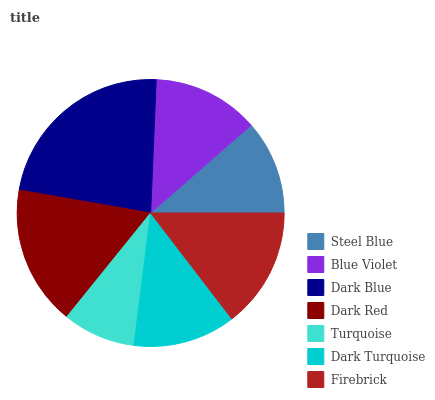Is Turquoise the minimum?
Answer yes or no. Yes. Is Dark Blue the maximum?
Answer yes or no. Yes. Is Blue Violet the minimum?
Answer yes or no. No. Is Blue Violet the maximum?
Answer yes or no. No. Is Blue Violet greater than Steel Blue?
Answer yes or no. Yes. Is Steel Blue less than Blue Violet?
Answer yes or no. Yes. Is Steel Blue greater than Blue Violet?
Answer yes or no. No. Is Blue Violet less than Steel Blue?
Answer yes or no. No. Is Blue Violet the high median?
Answer yes or no. Yes. Is Blue Violet the low median?
Answer yes or no. Yes. Is Dark Blue the high median?
Answer yes or no. No. Is Dark Red the low median?
Answer yes or no. No. 